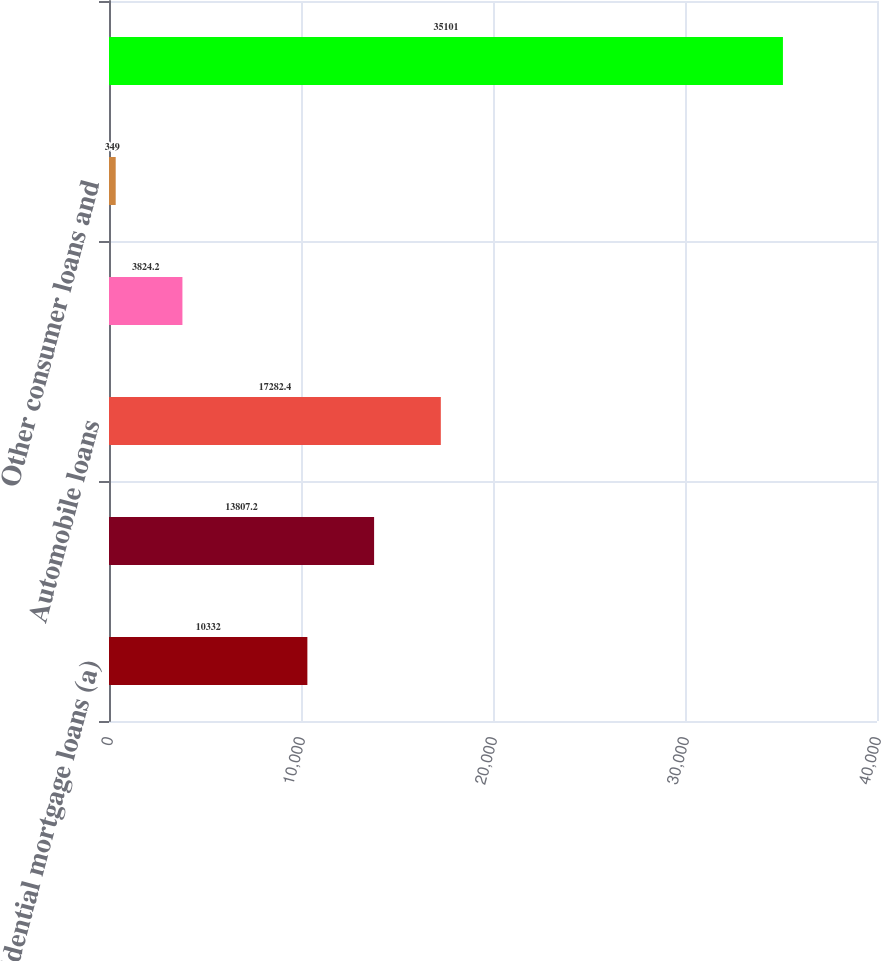Convert chart to OTSL. <chart><loc_0><loc_0><loc_500><loc_500><bar_chart><fcel>Residential mortgage loans (a)<fcel>Home equity<fcel>Automobile loans<fcel>Credit card<fcel>Other consumer loans and<fcel>Total<nl><fcel>10332<fcel>13807.2<fcel>17282.4<fcel>3824.2<fcel>349<fcel>35101<nl></chart> 